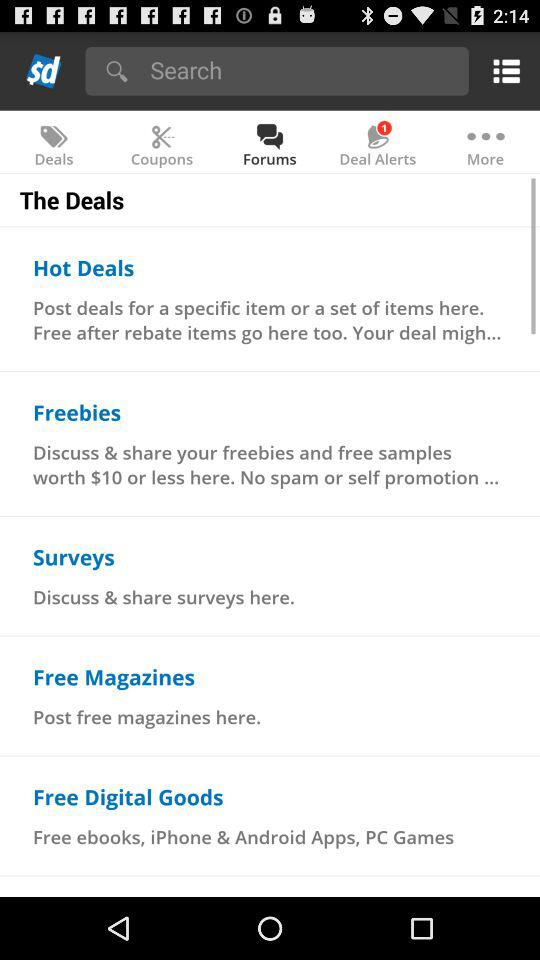What is the description given for hot deals? The description is "Post deals for a specific item or a set of items here. Free after rebate items go here too. Your deal migh...". 